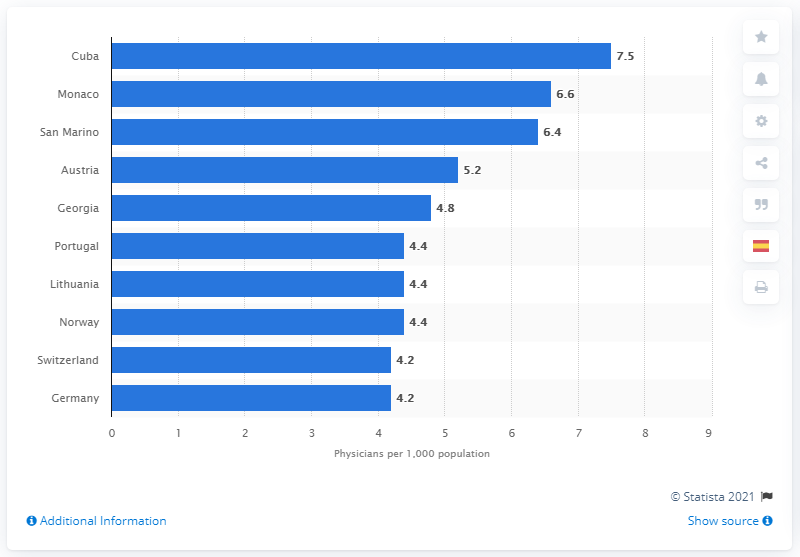List a handful of essential elements in this visual. Cuba had the highest number of physicians in relation to its population among all countries. In Cuba, there were approximately 7.5 physicians per 1,000 people in the population. 